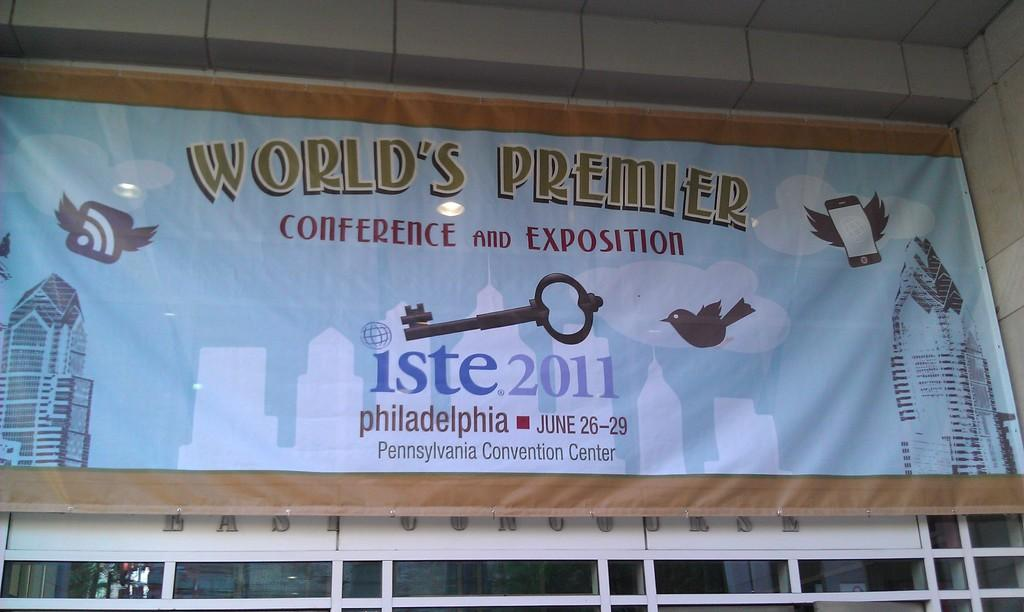Provide a one-sentence caption for the provided image. The worlds premier Conference and Exposition in Philadelphia. 